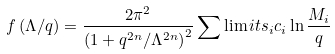Convert formula to latex. <formula><loc_0><loc_0><loc_500><loc_500>f \left ( \Lambda / q \right ) = \frac { 2 \pi ^ { 2 } } { \left ( 1 + q ^ { 2 n } / \Lambda ^ { 2 n } \right ) ^ { 2 } } \sum \lim i t s _ { i } c _ { i } \ln \frac { M _ { i } } { q }</formula> 